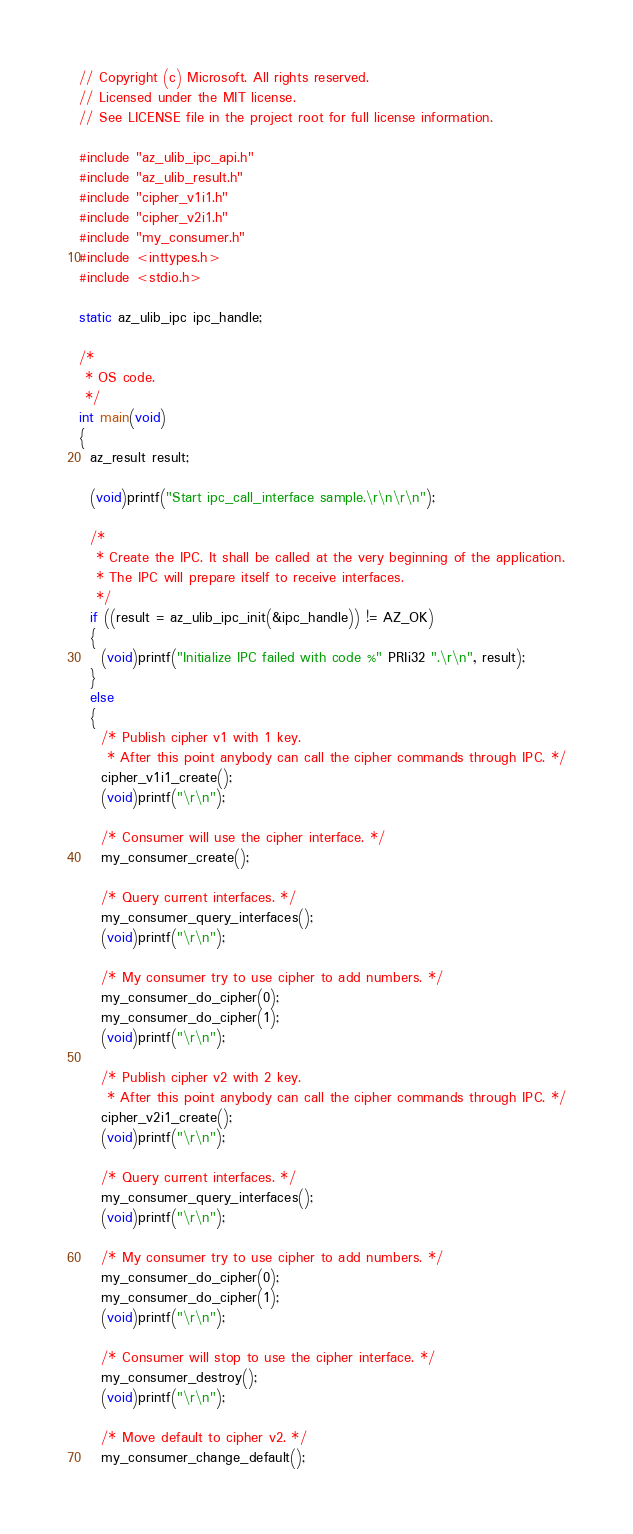<code> <loc_0><loc_0><loc_500><loc_500><_C_>// Copyright (c) Microsoft. All rights reserved.
// Licensed under the MIT license.
// See LICENSE file in the project root for full license information.

#include "az_ulib_ipc_api.h"
#include "az_ulib_result.h"
#include "cipher_v1i1.h"
#include "cipher_v2i1.h"
#include "my_consumer.h"
#include <inttypes.h>
#include <stdio.h>

static az_ulib_ipc ipc_handle;

/*
 * OS code.
 */
int main(void)
{
  az_result result;

  (void)printf("Start ipc_call_interface sample.\r\n\r\n");

  /*
   * Create the IPC. It shall be called at the very beginning of the application.
   * The IPC will prepare itself to receive interfaces.
   */
  if ((result = az_ulib_ipc_init(&ipc_handle)) != AZ_OK)
  {
    (void)printf("Initialize IPC failed with code %" PRIi32 ".\r\n", result);
  }
  else
  {
    /* Publish cipher v1 with 1 key.
     * After this point anybody can call the cipher commands through IPC. */
    cipher_v1i1_create();
    (void)printf("\r\n");

    /* Consumer will use the cipher interface. */
    my_consumer_create();

    /* Query current interfaces. */
    my_consumer_query_interfaces();
    (void)printf("\r\n");

    /* My consumer try to use cipher to add numbers. */
    my_consumer_do_cipher(0);
    my_consumer_do_cipher(1);
    (void)printf("\r\n");

    /* Publish cipher v2 with 2 key.
     * After this point anybody can call the cipher commands through IPC. */
    cipher_v2i1_create();
    (void)printf("\r\n");

    /* Query current interfaces. */
    my_consumer_query_interfaces();
    (void)printf("\r\n");

    /* My consumer try to use cipher to add numbers. */
    my_consumer_do_cipher(0);
    my_consumer_do_cipher(1);
    (void)printf("\r\n");

    /* Consumer will stop to use the cipher interface. */
    my_consumer_destroy();
    (void)printf("\r\n");

    /* Move default to cipher v2. */
    my_consumer_change_default();
</code> 